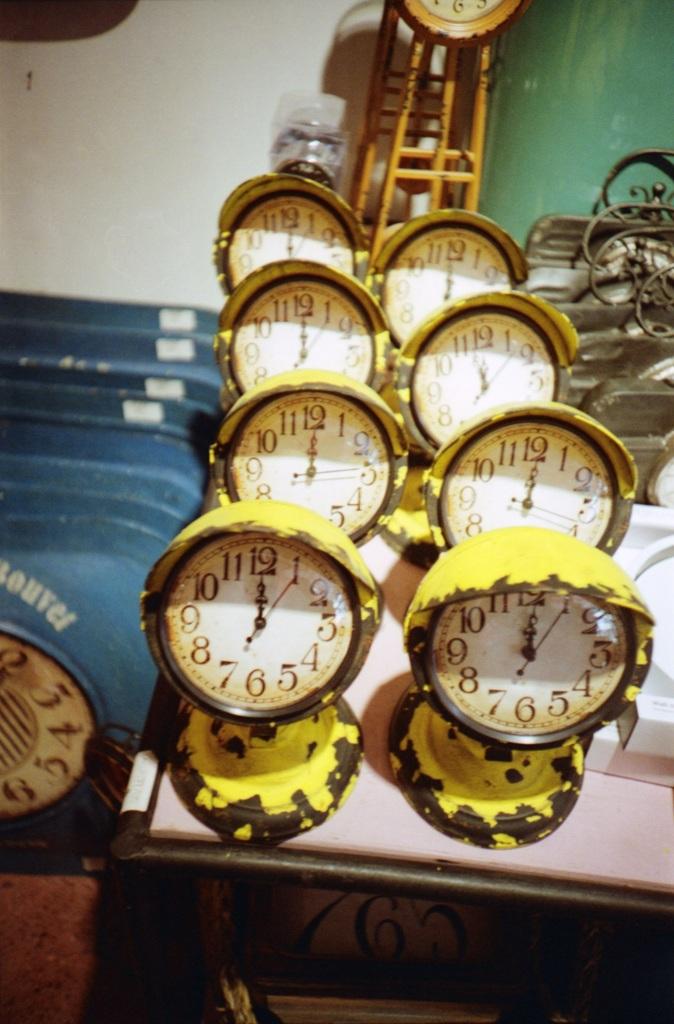What time is the clock on the bottom right?
Offer a terse response. 12:00. What number is at the top of the clock?
Offer a very short reply. 12. 